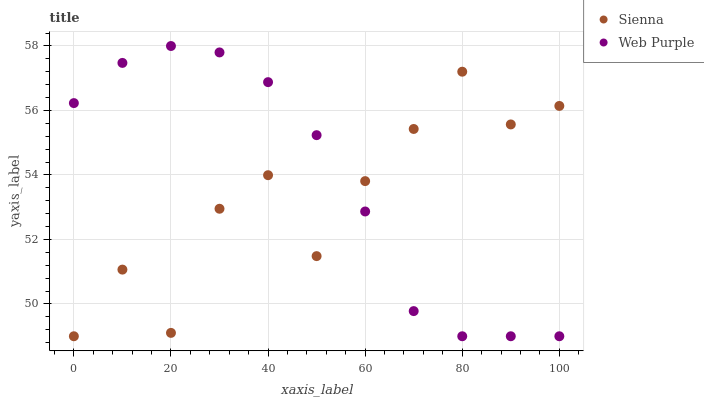Does Sienna have the minimum area under the curve?
Answer yes or no. Yes. Does Web Purple have the maximum area under the curve?
Answer yes or no. Yes. Does Web Purple have the minimum area under the curve?
Answer yes or no. No. Is Web Purple the smoothest?
Answer yes or no. Yes. Is Sienna the roughest?
Answer yes or no. Yes. Is Web Purple the roughest?
Answer yes or no. No. Does Sienna have the lowest value?
Answer yes or no. Yes. Does Web Purple have the highest value?
Answer yes or no. Yes. Does Sienna intersect Web Purple?
Answer yes or no. Yes. Is Sienna less than Web Purple?
Answer yes or no. No. Is Sienna greater than Web Purple?
Answer yes or no. No. 